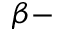<formula> <loc_0><loc_0><loc_500><loc_500>\beta -</formula> 